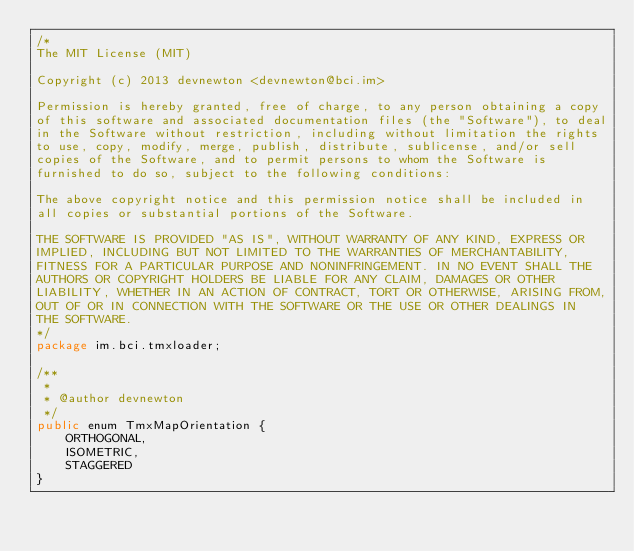<code> <loc_0><loc_0><loc_500><loc_500><_Java_>/*
The MIT License (MIT)

Copyright (c) 2013 devnewton <devnewton@bci.im>

Permission is hereby granted, free of charge, to any person obtaining a copy
of this software and associated documentation files (the "Software"), to deal
in the Software without restriction, including without limitation the rights
to use, copy, modify, merge, publish, distribute, sublicense, and/or sell
copies of the Software, and to permit persons to whom the Software is
furnished to do so, subject to the following conditions:

The above copyright notice and this permission notice shall be included in
all copies or substantial portions of the Software.

THE SOFTWARE IS PROVIDED "AS IS", WITHOUT WARRANTY OF ANY KIND, EXPRESS OR
IMPLIED, INCLUDING BUT NOT LIMITED TO THE WARRANTIES OF MERCHANTABILITY,
FITNESS FOR A PARTICULAR PURPOSE AND NONINFRINGEMENT. IN NO EVENT SHALL THE
AUTHORS OR COPYRIGHT HOLDERS BE LIABLE FOR ANY CLAIM, DAMAGES OR OTHER
LIABILITY, WHETHER IN AN ACTION OF CONTRACT, TORT OR OTHERWISE, ARISING FROM,
OUT OF OR IN CONNECTION WITH THE SOFTWARE OR THE USE OR OTHER DEALINGS IN
THE SOFTWARE.
*/
package im.bci.tmxloader;

/**
 *
 * @author devnewton
 */
public enum TmxMapOrientation {
    ORTHOGONAL,
    ISOMETRIC,
    STAGGERED    
}
</code> 